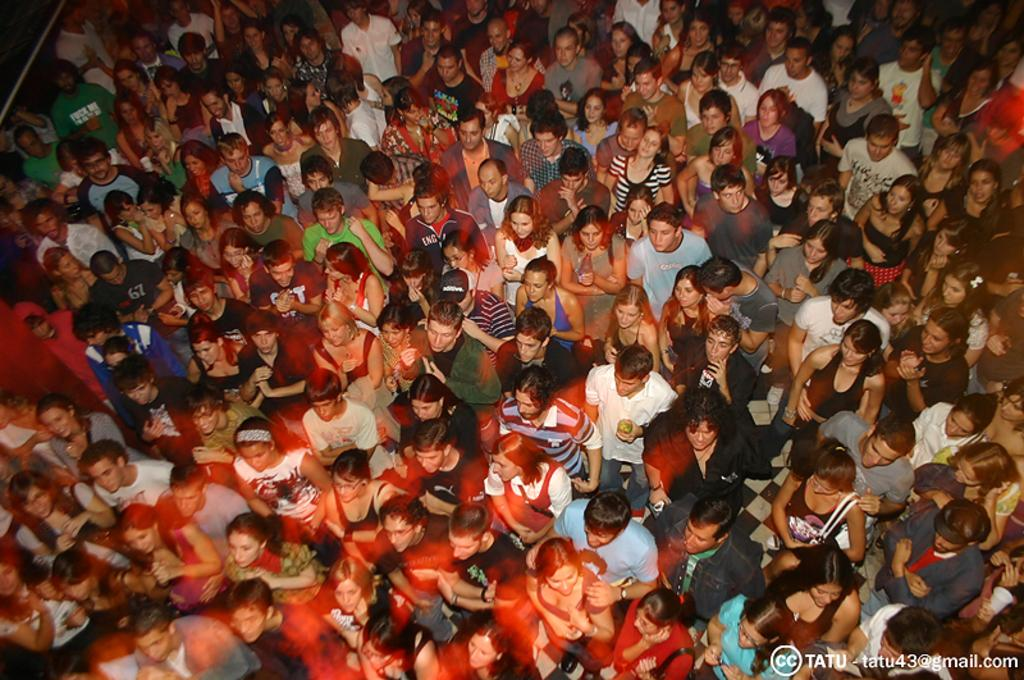What is the main subject of the image? The main subject of the image is a crowd. Can you describe the crowd in the image? Unfortunately, the provided facts do not give any details about the crowd, such as their age, gender, or activities. What time does the clock in the image show? There is no clock present in the image, so it is not possible to determine the time. 